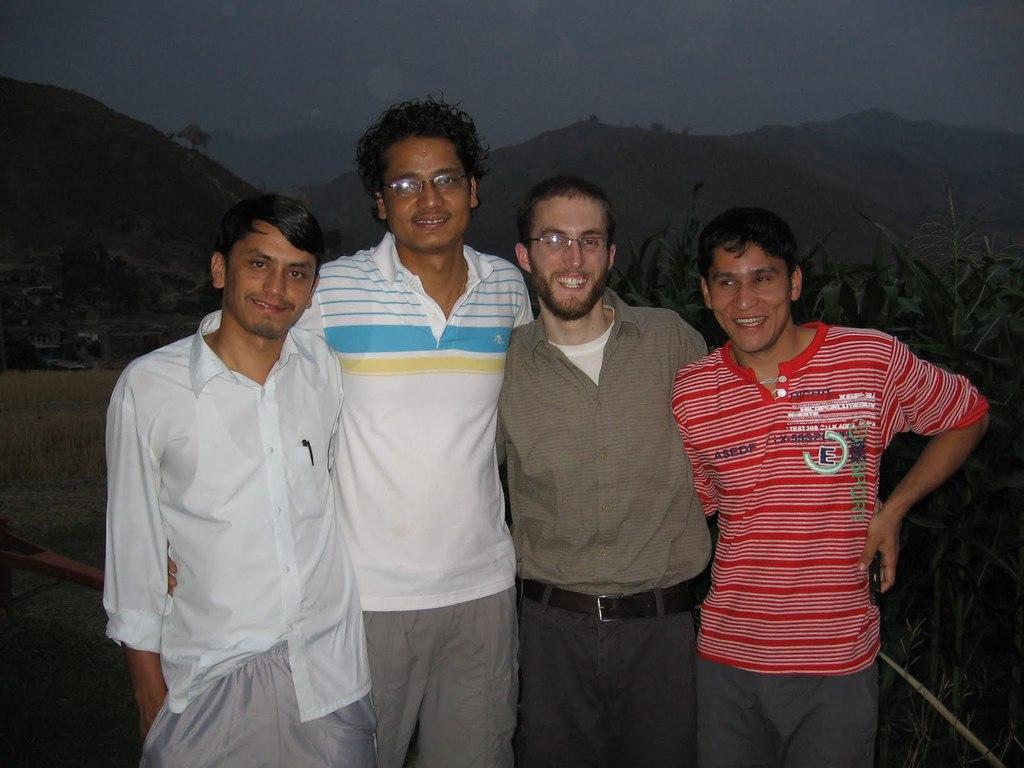In one or two sentences, can you explain what this image depicts? In this image in the front there are persons standing and smiling. In the background there are plants and there are mountains and there is dry grass on the ground. 